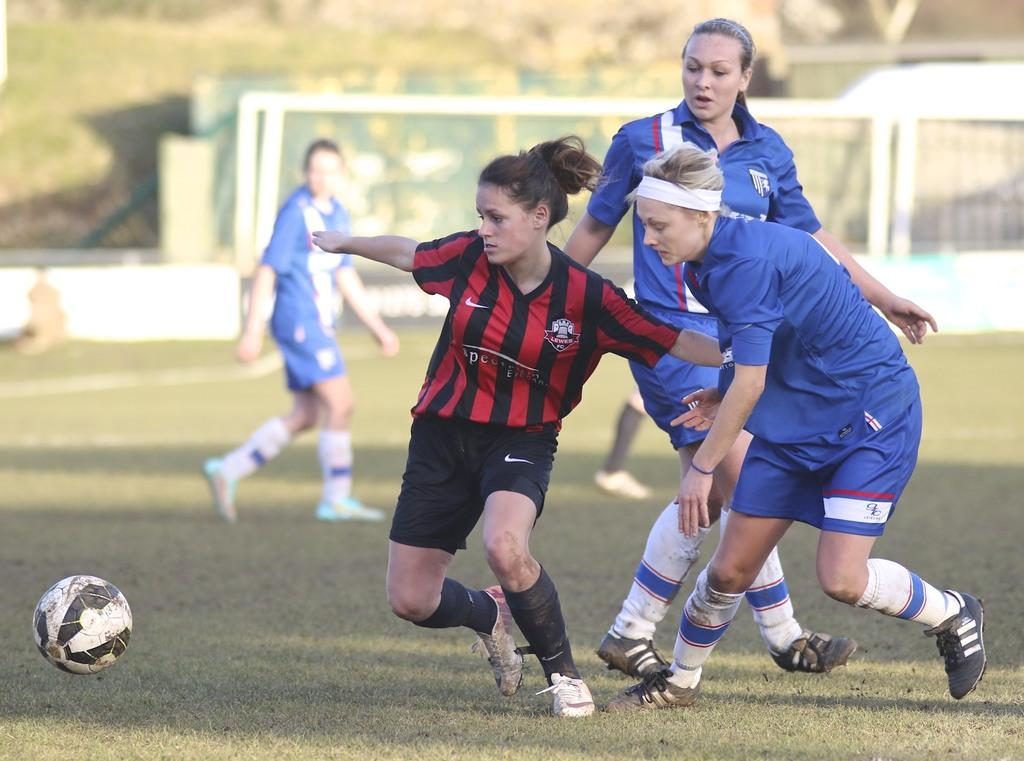What object can be seen in the image? There is a ball in the image. Who is present in the image? There is a group of women in the image. What are the women doing in the image? Some women are walking, and some are running. What can be seen under the women's feet in the image? The ground is visible in the image. What type of vegetation is visible in the background of the image? There is grass in the background of the image. How would you describe the quality of the background in the image? The background is blurry. What hobbies do the women have in common, as seen in the image? The image does not provide information about the women's hobbies, so we cannot determine their common interests. --- Facts: 1. There is a car in the image. 2. The car is red. 3. The car has four wheels. 4. There are people in the car. 5. The car is parked on the street. 6. There are trees on the side of the street. Absurd Topics: dance, ocean, smell Conversation: What vehicle is visible in the image? There is a car in the image. What color is the car? The car is red. How many wheels does the car have? The car has four wheels. Who is inside the car? There are people in the car. Where is the car located in the image? The car is parked on the street. What type of vegetation can be seen near the car? There are trees on the side of the street. Reasoning: Let's think step by step in order to produce the conversation. We start by identifying the main subject in the image, which is the car. Then, we describe the car's color and the number of wheels it has. Next, we mention the people inside the car and their location, which is parked on the street. Finally, we describe the surrounding environment, noting the presence of trees. Absurd Question/Answer: What type of dance can be seen taking place near the car in the image? There is no dance taking place near the car in the image; it only shows a parked red car with people inside. --- Facts: 1. There is a dog in the image. 2. The dog is brown. 3. The dog is sitting on a chair. 4. There is a table in the image. 5. There are books on the table. 6. The background of the image is a room. Absurd Topics: swim, mountain, taste Conversation: What animal is visible in the image? There is a dog in the image. What color is the dog? The 